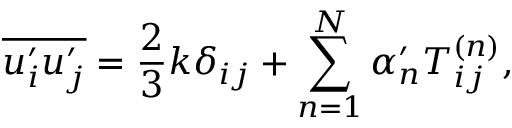<formula> <loc_0><loc_0><loc_500><loc_500>\overline { { u _ { i } ^ { \prime } u _ { j } ^ { \prime } } } = \frac { 2 } { 3 } k \delta _ { i j } + \sum _ { n = 1 } ^ { N } \alpha _ { n } ^ { \prime } T _ { i j } ^ { \left ( n \right ) } ,</formula> 